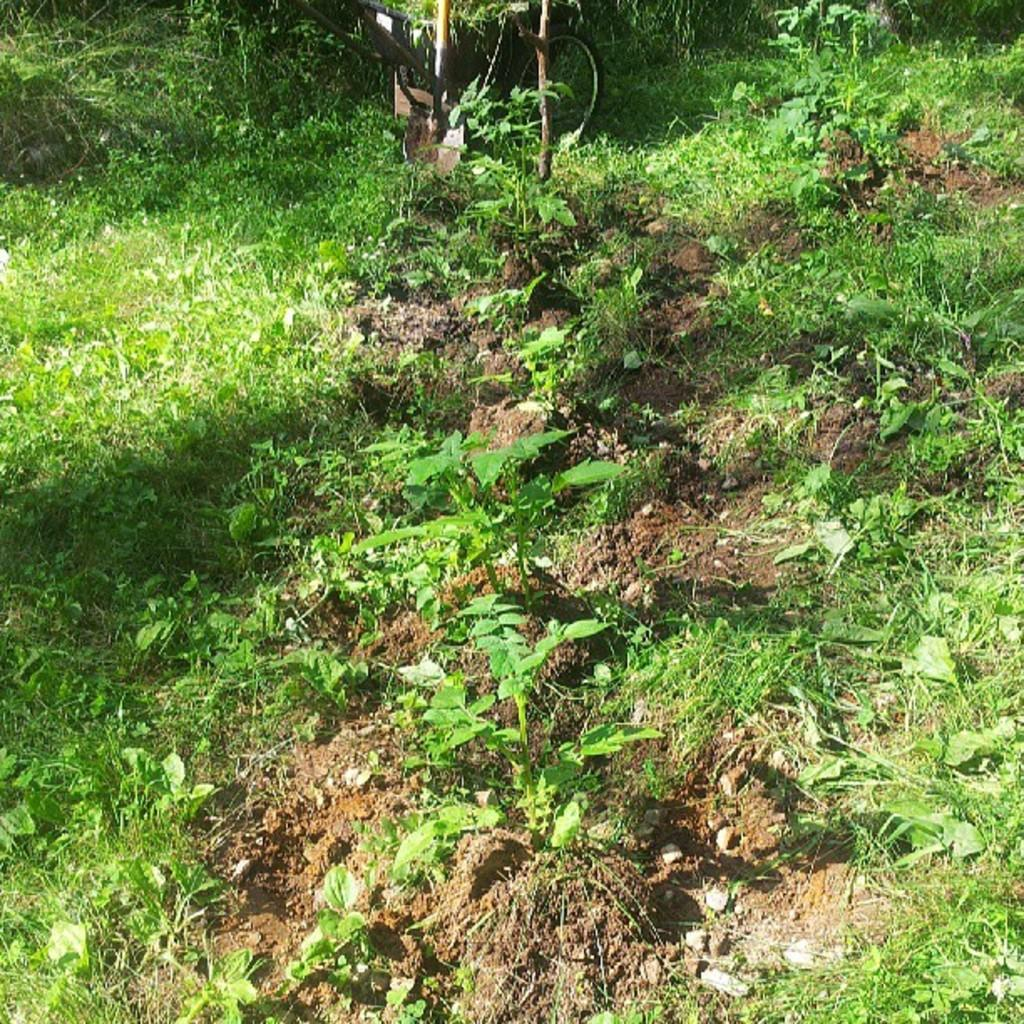What type of vegetation can be seen in the image? There is grass and plants visible in the image. What natural element is present in the image? There is water visible in the image. What type of terrain is shown in the image? There is mud in the image. What mode of transportation can be seen in the image? There is a cycle in the image. Who is wearing a crown in the image? There is no one wearing a crown in the image. What type of punishment is being administered in the image? There is no punishment being administered in the image. 